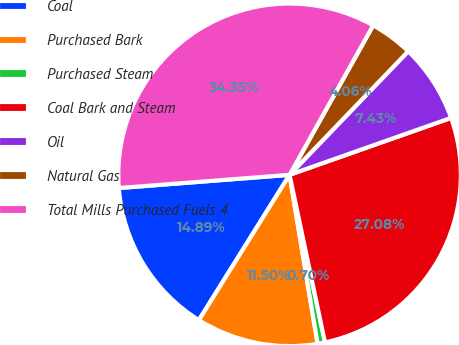<chart> <loc_0><loc_0><loc_500><loc_500><pie_chart><fcel>Coal<fcel>Purchased Bark<fcel>Purchased Steam<fcel>Coal Bark and Steam<fcel>Oil<fcel>Natural Gas<fcel>Total Mills Purchased Fuels 4<nl><fcel>14.89%<fcel>11.5%<fcel>0.7%<fcel>27.08%<fcel>7.43%<fcel>4.06%<fcel>34.35%<nl></chart> 